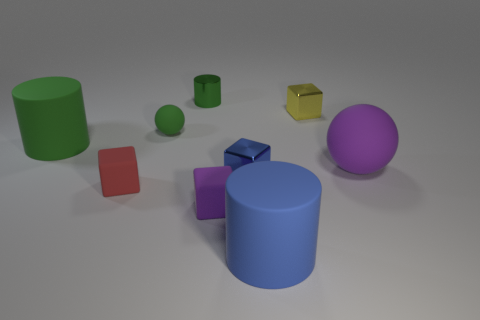Is the size of the red matte thing the same as the green shiny thing?
Your response must be concise. Yes. What is the size of the ball left of the purple matte object on the left side of the blue shiny object?
Offer a terse response. Small. What size is the object that is both in front of the big rubber ball and left of the tiny green shiny cylinder?
Provide a short and direct response. Small. What number of yellow blocks are the same size as the yellow thing?
Ensure brevity in your answer.  0. What number of matte objects are either small purple cubes or green objects?
Your answer should be compact. 3. There is a rubber object that is the same color as the small ball; what is its size?
Ensure brevity in your answer.  Large. There is a tiny object that is behind the tiny metal block behind the big sphere; what is it made of?
Offer a very short reply. Metal. How many things are either tiny red matte cubes or small matte blocks that are behind the small purple matte thing?
Ensure brevity in your answer.  1. What size is the blue thing that is made of the same material as the small cylinder?
Offer a very short reply. Small. How many red objects are either rubber balls or tiny blocks?
Offer a very short reply. 1. 